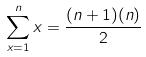Convert formula to latex. <formula><loc_0><loc_0><loc_500><loc_500>\sum _ { x = 1 } ^ { n } x = \frac { ( n + 1 ) ( n ) } { 2 }</formula> 